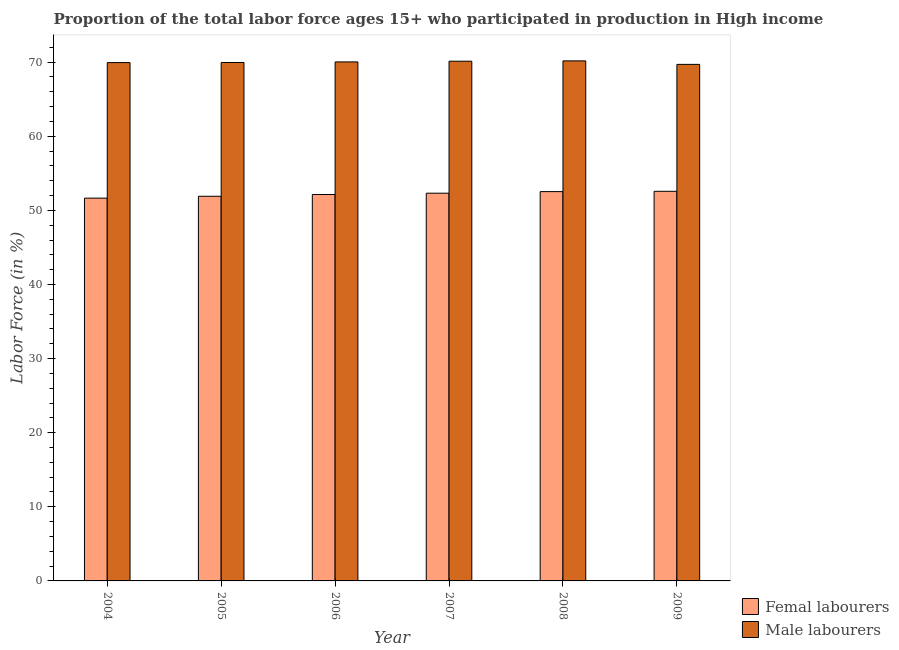How many different coloured bars are there?
Your response must be concise. 2. How many groups of bars are there?
Your response must be concise. 6. Are the number of bars per tick equal to the number of legend labels?
Keep it short and to the point. Yes. Are the number of bars on each tick of the X-axis equal?
Your response must be concise. Yes. What is the percentage of female labor force in 2009?
Keep it short and to the point. 52.57. Across all years, what is the maximum percentage of female labor force?
Provide a short and direct response. 52.57. Across all years, what is the minimum percentage of female labor force?
Keep it short and to the point. 51.65. What is the total percentage of male labour force in the graph?
Your response must be concise. 419.91. What is the difference between the percentage of female labor force in 2005 and that in 2006?
Provide a succinct answer. -0.24. What is the difference between the percentage of male labour force in 2008 and the percentage of female labor force in 2007?
Offer a very short reply. 0.04. What is the average percentage of female labor force per year?
Keep it short and to the point. 52.18. In the year 2006, what is the difference between the percentage of male labour force and percentage of female labor force?
Give a very brief answer. 0. What is the ratio of the percentage of female labor force in 2004 to that in 2008?
Offer a terse response. 0.98. What is the difference between the highest and the second highest percentage of male labour force?
Your response must be concise. 0.04. What is the difference between the highest and the lowest percentage of female labor force?
Offer a terse response. 0.92. In how many years, is the percentage of female labor force greater than the average percentage of female labor force taken over all years?
Give a very brief answer. 3. What does the 1st bar from the left in 2006 represents?
Give a very brief answer. Femal labourers. What does the 1st bar from the right in 2005 represents?
Provide a short and direct response. Male labourers. How many bars are there?
Offer a terse response. 12. How many years are there in the graph?
Offer a terse response. 6. Does the graph contain any zero values?
Ensure brevity in your answer.  No. Where does the legend appear in the graph?
Provide a succinct answer. Bottom right. What is the title of the graph?
Offer a terse response. Proportion of the total labor force ages 15+ who participated in production in High income. Does "Official creditors" appear as one of the legend labels in the graph?
Ensure brevity in your answer.  No. What is the label or title of the Y-axis?
Keep it short and to the point. Labor Force (in %). What is the Labor Force (in %) in Femal labourers in 2004?
Your answer should be very brief. 51.65. What is the Labor Force (in %) in Male labourers in 2004?
Provide a short and direct response. 69.94. What is the Labor Force (in %) in Femal labourers in 2005?
Make the answer very short. 51.9. What is the Labor Force (in %) in Male labourers in 2005?
Your answer should be compact. 69.95. What is the Labor Force (in %) of Femal labourers in 2006?
Keep it short and to the point. 52.14. What is the Labor Force (in %) in Male labourers in 2006?
Ensure brevity in your answer.  70.03. What is the Labor Force (in %) of Femal labourers in 2007?
Give a very brief answer. 52.32. What is the Labor Force (in %) of Male labourers in 2007?
Ensure brevity in your answer.  70.13. What is the Labor Force (in %) of Femal labourers in 2008?
Your response must be concise. 52.53. What is the Labor Force (in %) of Male labourers in 2008?
Make the answer very short. 70.17. What is the Labor Force (in %) of Femal labourers in 2009?
Your answer should be compact. 52.57. What is the Labor Force (in %) in Male labourers in 2009?
Provide a succinct answer. 69.7. Across all years, what is the maximum Labor Force (in %) of Femal labourers?
Provide a succinct answer. 52.57. Across all years, what is the maximum Labor Force (in %) in Male labourers?
Provide a succinct answer. 70.17. Across all years, what is the minimum Labor Force (in %) of Femal labourers?
Your answer should be very brief. 51.65. Across all years, what is the minimum Labor Force (in %) of Male labourers?
Keep it short and to the point. 69.7. What is the total Labor Force (in %) of Femal labourers in the graph?
Your response must be concise. 313.1. What is the total Labor Force (in %) of Male labourers in the graph?
Provide a short and direct response. 419.91. What is the difference between the Labor Force (in %) in Femal labourers in 2004 and that in 2005?
Your answer should be very brief. -0.25. What is the difference between the Labor Force (in %) in Male labourers in 2004 and that in 2005?
Offer a terse response. -0.01. What is the difference between the Labor Force (in %) of Femal labourers in 2004 and that in 2006?
Offer a terse response. -0.49. What is the difference between the Labor Force (in %) of Male labourers in 2004 and that in 2006?
Provide a short and direct response. -0.09. What is the difference between the Labor Force (in %) of Femal labourers in 2004 and that in 2007?
Provide a succinct answer. -0.67. What is the difference between the Labor Force (in %) of Male labourers in 2004 and that in 2007?
Provide a succinct answer. -0.19. What is the difference between the Labor Force (in %) of Femal labourers in 2004 and that in 2008?
Your answer should be very brief. -0.88. What is the difference between the Labor Force (in %) of Male labourers in 2004 and that in 2008?
Provide a succinct answer. -0.23. What is the difference between the Labor Force (in %) in Femal labourers in 2004 and that in 2009?
Provide a short and direct response. -0.92. What is the difference between the Labor Force (in %) of Male labourers in 2004 and that in 2009?
Make the answer very short. 0.24. What is the difference between the Labor Force (in %) of Femal labourers in 2005 and that in 2006?
Make the answer very short. -0.24. What is the difference between the Labor Force (in %) in Male labourers in 2005 and that in 2006?
Provide a short and direct response. -0.08. What is the difference between the Labor Force (in %) in Femal labourers in 2005 and that in 2007?
Give a very brief answer. -0.42. What is the difference between the Labor Force (in %) of Male labourers in 2005 and that in 2007?
Ensure brevity in your answer.  -0.17. What is the difference between the Labor Force (in %) of Femal labourers in 2005 and that in 2008?
Make the answer very short. -0.63. What is the difference between the Labor Force (in %) in Male labourers in 2005 and that in 2008?
Offer a very short reply. -0.22. What is the difference between the Labor Force (in %) in Femal labourers in 2005 and that in 2009?
Your answer should be compact. -0.67. What is the difference between the Labor Force (in %) in Male labourers in 2005 and that in 2009?
Make the answer very short. 0.26. What is the difference between the Labor Force (in %) of Femal labourers in 2006 and that in 2007?
Ensure brevity in your answer.  -0.18. What is the difference between the Labor Force (in %) in Male labourers in 2006 and that in 2007?
Provide a succinct answer. -0.1. What is the difference between the Labor Force (in %) of Femal labourers in 2006 and that in 2008?
Your response must be concise. -0.39. What is the difference between the Labor Force (in %) of Male labourers in 2006 and that in 2008?
Your answer should be very brief. -0.14. What is the difference between the Labor Force (in %) in Femal labourers in 2006 and that in 2009?
Provide a short and direct response. -0.43. What is the difference between the Labor Force (in %) in Male labourers in 2006 and that in 2009?
Your answer should be very brief. 0.33. What is the difference between the Labor Force (in %) in Femal labourers in 2007 and that in 2008?
Provide a succinct answer. -0.21. What is the difference between the Labor Force (in %) in Male labourers in 2007 and that in 2008?
Provide a succinct answer. -0.04. What is the difference between the Labor Force (in %) of Femal labourers in 2007 and that in 2009?
Your answer should be very brief. -0.25. What is the difference between the Labor Force (in %) of Male labourers in 2007 and that in 2009?
Offer a very short reply. 0.43. What is the difference between the Labor Force (in %) in Femal labourers in 2008 and that in 2009?
Offer a very short reply. -0.04. What is the difference between the Labor Force (in %) in Male labourers in 2008 and that in 2009?
Your response must be concise. 0.47. What is the difference between the Labor Force (in %) of Femal labourers in 2004 and the Labor Force (in %) of Male labourers in 2005?
Give a very brief answer. -18.3. What is the difference between the Labor Force (in %) of Femal labourers in 2004 and the Labor Force (in %) of Male labourers in 2006?
Provide a succinct answer. -18.38. What is the difference between the Labor Force (in %) of Femal labourers in 2004 and the Labor Force (in %) of Male labourers in 2007?
Your answer should be very brief. -18.48. What is the difference between the Labor Force (in %) in Femal labourers in 2004 and the Labor Force (in %) in Male labourers in 2008?
Your response must be concise. -18.52. What is the difference between the Labor Force (in %) in Femal labourers in 2004 and the Labor Force (in %) in Male labourers in 2009?
Give a very brief answer. -18.05. What is the difference between the Labor Force (in %) in Femal labourers in 2005 and the Labor Force (in %) in Male labourers in 2006?
Provide a short and direct response. -18.13. What is the difference between the Labor Force (in %) in Femal labourers in 2005 and the Labor Force (in %) in Male labourers in 2007?
Your answer should be very brief. -18.23. What is the difference between the Labor Force (in %) of Femal labourers in 2005 and the Labor Force (in %) of Male labourers in 2008?
Your answer should be very brief. -18.27. What is the difference between the Labor Force (in %) in Femal labourers in 2005 and the Labor Force (in %) in Male labourers in 2009?
Provide a succinct answer. -17.8. What is the difference between the Labor Force (in %) of Femal labourers in 2006 and the Labor Force (in %) of Male labourers in 2007?
Provide a short and direct response. -17.99. What is the difference between the Labor Force (in %) in Femal labourers in 2006 and the Labor Force (in %) in Male labourers in 2008?
Ensure brevity in your answer.  -18.03. What is the difference between the Labor Force (in %) of Femal labourers in 2006 and the Labor Force (in %) of Male labourers in 2009?
Provide a short and direct response. -17.56. What is the difference between the Labor Force (in %) of Femal labourers in 2007 and the Labor Force (in %) of Male labourers in 2008?
Ensure brevity in your answer.  -17.85. What is the difference between the Labor Force (in %) of Femal labourers in 2007 and the Labor Force (in %) of Male labourers in 2009?
Offer a terse response. -17.38. What is the difference between the Labor Force (in %) of Femal labourers in 2008 and the Labor Force (in %) of Male labourers in 2009?
Provide a succinct answer. -17.17. What is the average Labor Force (in %) in Femal labourers per year?
Keep it short and to the point. 52.18. What is the average Labor Force (in %) of Male labourers per year?
Offer a very short reply. 69.98. In the year 2004, what is the difference between the Labor Force (in %) of Femal labourers and Labor Force (in %) of Male labourers?
Provide a succinct answer. -18.29. In the year 2005, what is the difference between the Labor Force (in %) in Femal labourers and Labor Force (in %) in Male labourers?
Offer a terse response. -18.05. In the year 2006, what is the difference between the Labor Force (in %) of Femal labourers and Labor Force (in %) of Male labourers?
Your response must be concise. -17.89. In the year 2007, what is the difference between the Labor Force (in %) in Femal labourers and Labor Force (in %) in Male labourers?
Keep it short and to the point. -17.81. In the year 2008, what is the difference between the Labor Force (in %) in Femal labourers and Labor Force (in %) in Male labourers?
Provide a succinct answer. -17.64. In the year 2009, what is the difference between the Labor Force (in %) of Femal labourers and Labor Force (in %) of Male labourers?
Provide a succinct answer. -17.12. What is the ratio of the Labor Force (in %) of Femal labourers in 2004 to that in 2005?
Offer a terse response. 1. What is the ratio of the Labor Force (in %) of Femal labourers in 2004 to that in 2006?
Keep it short and to the point. 0.99. What is the ratio of the Labor Force (in %) in Femal labourers in 2004 to that in 2007?
Provide a succinct answer. 0.99. What is the ratio of the Labor Force (in %) in Male labourers in 2004 to that in 2007?
Make the answer very short. 1. What is the ratio of the Labor Force (in %) in Femal labourers in 2004 to that in 2008?
Provide a short and direct response. 0.98. What is the ratio of the Labor Force (in %) in Male labourers in 2004 to that in 2008?
Provide a short and direct response. 1. What is the ratio of the Labor Force (in %) in Femal labourers in 2004 to that in 2009?
Keep it short and to the point. 0.98. What is the ratio of the Labor Force (in %) in Male labourers in 2004 to that in 2009?
Offer a terse response. 1. What is the ratio of the Labor Force (in %) in Femal labourers in 2005 to that in 2006?
Give a very brief answer. 1. What is the ratio of the Labor Force (in %) in Male labourers in 2005 to that in 2006?
Give a very brief answer. 1. What is the ratio of the Labor Force (in %) in Femal labourers in 2005 to that in 2007?
Keep it short and to the point. 0.99. What is the ratio of the Labor Force (in %) of Male labourers in 2005 to that in 2007?
Provide a short and direct response. 1. What is the ratio of the Labor Force (in %) in Femal labourers in 2005 to that in 2008?
Keep it short and to the point. 0.99. What is the ratio of the Labor Force (in %) in Male labourers in 2005 to that in 2008?
Your answer should be very brief. 1. What is the ratio of the Labor Force (in %) in Femal labourers in 2005 to that in 2009?
Keep it short and to the point. 0.99. What is the ratio of the Labor Force (in %) of Femal labourers in 2006 to that in 2007?
Make the answer very short. 1. What is the ratio of the Labor Force (in %) of Male labourers in 2006 to that in 2007?
Make the answer very short. 1. What is the ratio of the Labor Force (in %) in Femal labourers in 2006 to that in 2009?
Make the answer very short. 0.99. What is the ratio of the Labor Force (in %) of Femal labourers in 2007 to that in 2008?
Offer a terse response. 1. What is the ratio of the Labor Force (in %) in Male labourers in 2008 to that in 2009?
Provide a succinct answer. 1.01. What is the difference between the highest and the second highest Labor Force (in %) of Femal labourers?
Provide a short and direct response. 0.04. What is the difference between the highest and the second highest Labor Force (in %) of Male labourers?
Ensure brevity in your answer.  0.04. What is the difference between the highest and the lowest Labor Force (in %) of Femal labourers?
Make the answer very short. 0.92. What is the difference between the highest and the lowest Labor Force (in %) of Male labourers?
Your answer should be compact. 0.47. 